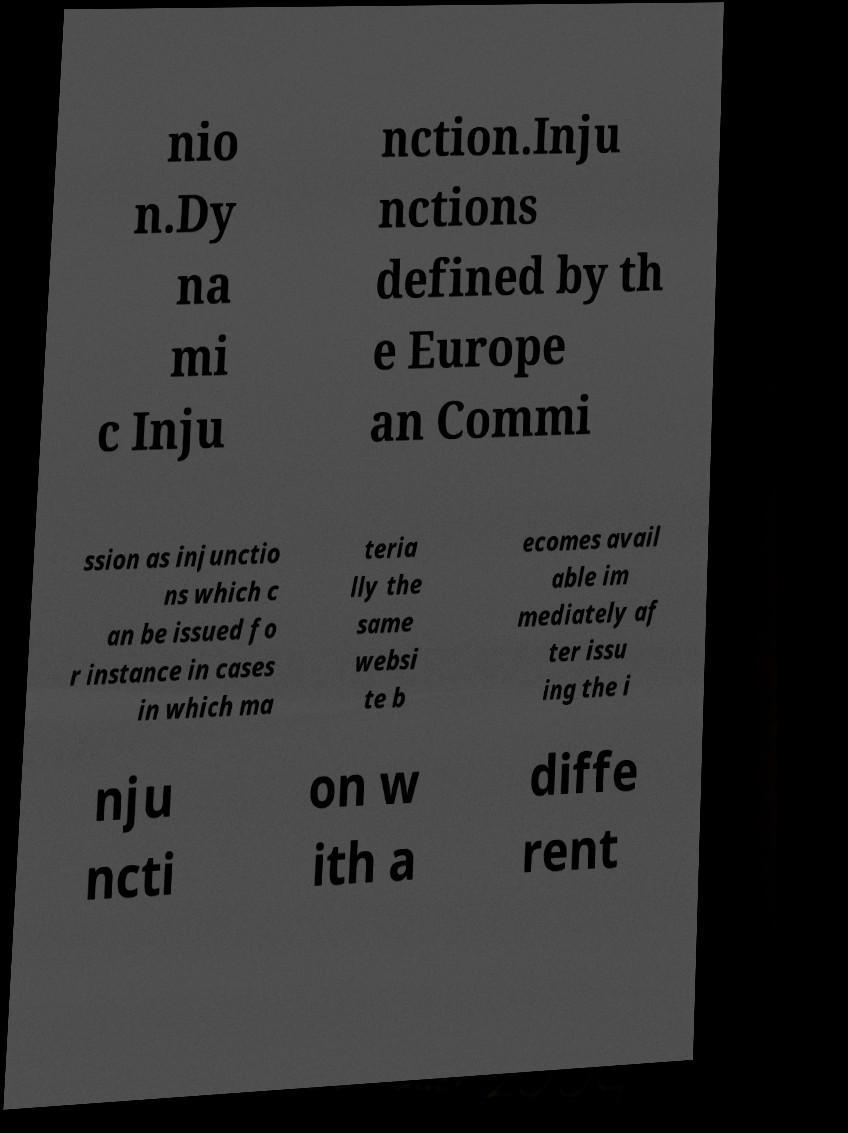Can you read and provide the text displayed in the image?This photo seems to have some interesting text. Can you extract and type it out for me? nio n.Dy na mi c Inju nction.Inju nctions defined by th e Europe an Commi ssion as injunctio ns which c an be issued fo r instance in cases in which ma teria lly the same websi te b ecomes avail able im mediately af ter issu ing the i nju ncti on w ith a diffe rent 